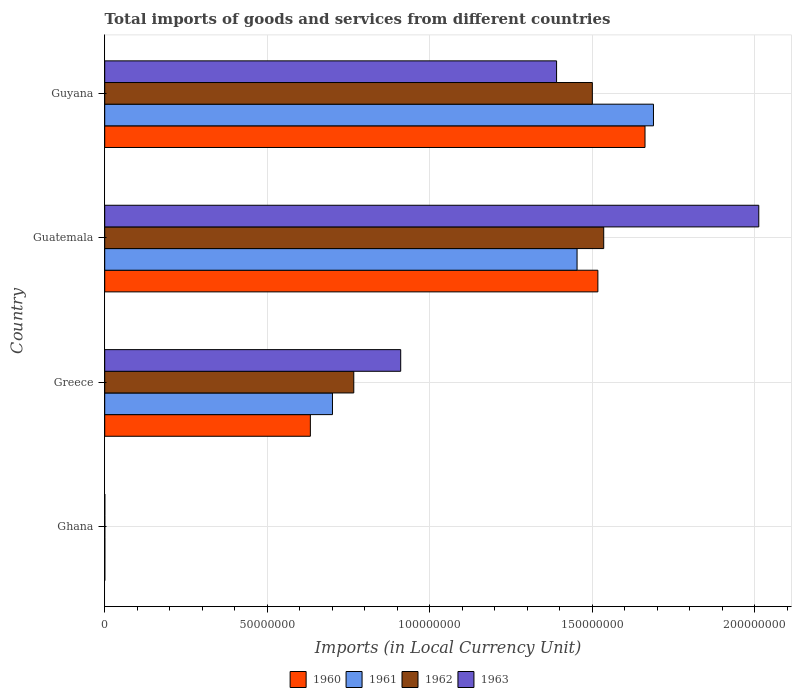How many bars are there on the 2nd tick from the bottom?
Keep it short and to the point. 4. What is the Amount of goods and services imports in 1960 in Guatemala?
Your response must be concise. 1.52e+08. Across all countries, what is the maximum Amount of goods and services imports in 1961?
Your answer should be very brief. 1.69e+08. Across all countries, what is the minimum Amount of goods and services imports in 1963?
Provide a succinct answer. 3.02e+04. In which country was the Amount of goods and services imports in 1963 maximum?
Make the answer very short. Guatemala. What is the total Amount of goods and services imports in 1962 in the graph?
Provide a short and direct response. 3.80e+08. What is the difference between the Amount of goods and services imports in 1963 in Ghana and that in Greece?
Make the answer very short. -9.10e+07. What is the difference between the Amount of goods and services imports in 1963 in Guyana and the Amount of goods and services imports in 1960 in Greece?
Give a very brief answer. 7.57e+07. What is the average Amount of goods and services imports in 1962 per country?
Give a very brief answer. 9.50e+07. What is the difference between the Amount of goods and services imports in 1963 and Amount of goods and services imports in 1960 in Guatemala?
Make the answer very short. 4.95e+07. In how many countries, is the Amount of goods and services imports in 1960 greater than 200000000 LCU?
Keep it short and to the point. 0. What is the ratio of the Amount of goods and services imports in 1961 in Greece to that in Guyana?
Your answer should be compact. 0.42. Is the Amount of goods and services imports in 1961 in Guatemala less than that in Guyana?
Ensure brevity in your answer.  Yes. Is the difference between the Amount of goods and services imports in 1963 in Guatemala and Guyana greater than the difference between the Amount of goods and services imports in 1960 in Guatemala and Guyana?
Your answer should be very brief. Yes. What is the difference between the highest and the second highest Amount of goods and services imports in 1960?
Ensure brevity in your answer.  1.45e+07. What is the difference between the highest and the lowest Amount of goods and services imports in 1960?
Offer a terse response. 1.66e+08. Is the sum of the Amount of goods and services imports in 1960 in Greece and Guatemala greater than the maximum Amount of goods and services imports in 1961 across all countries?
Offer a very short reply. Yes. What does the 1st bar from the top in Ghana represents?
Your answer should be compact. 1963. What does the 4th bar from the bottom in Ghana represents?
Offer a very short reply. 1963. How many countries are there in the graph?
Keep it short and to the point. 4. What is the difference between two consecutive major ticks on the X-axis?
Provide a succinct answer. 5.00e+07. Does the graph contain any zero values?
Provide a succinct answer. No. Does the graph contain grids?
Offer a very short reply. Yes. How many legend labels are there?
Provide a short and direct response. 4. What is the title of the graph?
Make the answer very short. Total imports of goods and services from different countries. What is the label or title of the X-axis?
Your response must be concise. Imports (in Local Currency Unit). What is the label or title of the Y-axis?
Give a very brief answer. Country. What is the Imports (in Local Currency Unit) in 1960 in Ghana?
Your answer should be very brief. 3.08e+04. What is the Imports (in Local Currency Unit) in 1961 in Ghana?
Offer a terse response. 3.39e+04. What is the Imports (in Local Currency Unit) in 1962 in Ghana?
Ensure brevity in your answer.  2.81e+04. What is the Imports (in Local Currency Unit) of 1963 in Ghana?
Offer a very short reply. 3.02e+04. What is the Imports (in Local Currency Unit) of 1960 in Greece?
Ensure brevity in your answer.  6.33e+07. What is the Imports (in Local Currency Unit) of 1961 in Greece?
Make the answer very short. 7.01e+07. What is the Imports (in Local Currency Unit) in 1962 in Greece?
Offer a very short reply. 7.66e+07. What is the Imports (in Local Currency Unit) in 1963 in Greece?
Your response must be concise. 9.10e+07. What is the Imports (in Local Currency Unit) of 1960 in Guatemala?
Ensure brevity in your answer.  1.52e+08. What is the Imports (in Local Currency Unit) in 1961 in Guatemala?
Offer a terse response. 1.45e+08. What is the Imports (in Local Currency Unit) of 1962 in Guatemala?
Provide a succinct answer. 1.54e+08. What is the Imports (in Local Currency Unit) in 1963 in Guatemala?
Your answer should be compact. 2.01e+08. What is the Imports (in Local Currency Unit) of 1960 in Guyana?
Make the answer very short. 1.66e+08. What is the Imports (in Local Currency Unit) of 1961 in Guyana?
Offer a very short reply. 1.69e+08. What is the Imports (in Local Currency Unit) of 1962 in Guyana?
Provide a short and direct response. 1.50e+08. What is the Imports (in Local Currency Unit) in 1963 in Guyana?
Your response must be concise. 1.39e+08. Across all countries, what is the maximum Imports (in Local Currency Unit) in 1960?
Keep it short and to the point. 1.66e+08. Across all countries, what is the maximum Imports (in Local Currency Unit) of 1961?
Your response must be concise. 1.69e+08. Across all countries, what is the maximum Imports (in Local Currency Unit) of 1962?
Keep it short and to the point. 1.54e+08. Across all countries, what is the maximum Imports (in Local Currency Unit) of 1963?
Offer a very short reply. 2.01e+08. Across all countries, what is the minimum Imports (in Local Currency Unit) of 1960?
Your answer should be very brief. 3.08e+04. Across all countries, what is the minimum Imports (in Local Currency Unit) in 1961?
Provide a short and direct response. 3.39e+04. Across all countries, what is the minimum Imports (in Local Currency Unit) in 1962?
Offer a terse response. 2.81e+04. Across all countries, what is the minimum Imports (in Local Currency Unit) of 1963?
Make the answer very short. 3.02e+04. What is the total Imports (in Local Currency Unit) of 1960 in the graph?
Provide a succinct answer. 3.81e+08. What is the total Imports (in Local Currency Unit) of 1961 in the graph?
Provide a short and direct response. 3.84e+08. What is the total Imports (in Local Currency Unit) of 1962 in the graph?
Give a very brief answer. 3.80e+08. What is the total Imports (in Local Currency Unit) of 1963 in the graph?
Make the answer very short. 4.31e+08. What is the difference between the Imports (in Local Currency Unit) of 1960 in Ghana and that in Greece?
Provide a short and direct response. -6.32e+07. What is the difference between the Imports (in Local Currency Unit) of 1961 in Ghana and that in Greece?
Ensure brevity in your answer.  -7.00e+07. What is the difference between the Imports (in Local Currency Unit) of 1962 in Ghana and that in Greece?
Ensure brevity in your answer.  -7.66e+07. What is the difference between the Imports (in Local Currency Unit) in 1963 in Ghana and that in Greece?
Your answer should be compact. -9.10e+07. What is the difference between the Imports (in Local Currency Unit) in 1960 in Ghana and that in Guatemala?
Keep it short and to the point. -1.52e+08. What is the difference between the Imports (in Local Currency Unit) of 1961 in Ghana and that in Guatemala?
Provide a succinct answer. -1.45e+08. What is the difference between the Imports (in Local Currency Unit) of 1962 in Ghana and that in Guatemala?
Provide a succinct answer. -1.53e+08. What is the difference between the Imports (in Local Currency Unit) of 1963 in Ghana and that in Guatemala?
Ensure brevity in your answer.  -2.01e+08. What is the difference between the Imports (in Local Currency Unit) in 1960 in Ghana and that in Guyana?
Provide a succinct answer. -1.66e+08. What is the difference between the Imports (in Local Currency Unit) in 1961 in Ghana and that in Guyana?
Keep it short and to the point. -1.69e+08. What is the difference between the Imports (in Local Currency Unit) of 1962 in Ghana and that in Guyana?
Your answer should be compact. -1.50e+08. What is the difference between the Imports (in Local Currency Unit) in 1963 in Ghana and that in Guyana?
Make the answer very short. -1.39e+08. What is the difference between the Imports (in Local Currency Unit) of 1960 in Greece and that in Guatemala?
Make the answer very short. -8.84e+07. What is the difference between the Imports (in Local Currency Unit) of 1961 in Greece and that in Guatemala?
Provide a succinct answer. -7.52e+07. What is the difference between the Imports (in Local Currency Unit) of 1962 in Greece and that in Guatemala?
Keep it short and to the point. -7.69e+07. What is the difference between the Imports (in Local Currency Unit) in 1963 in Greece and that in Guatemala?
Provide a short and direct response. -1.10e+08. What is the difference between the Imports (in Local Currency Unit) in 1960 in Greece and that in Guyana?
Your answer should be compact. -1.03e+08. What is the difference between the Imports (in Local Currency Unit) of 1961 in Greece and that in Guyana?
Your answer should be compact. -9.87e+07. What is the difference between the Imports (in Local Currency Unit) of 1962 in Greece and that in Guyana?
Your answer should be very brief. -7.34e+07. What is the difference between the Imports (in Local Currency Unit) in 1963 in Greece and that in Guyana?
Your response must be concise. -4.80e+07. What is the difference between the Imports (in Local Currency Unit) of 1960 in Guatemala and that in Guyana?
Give a very brief answer. -1.45e+07. What is the difference between the Imports (in Local Currency Unit) in 1961 in Guatemala and that in Guyana?
Provide a succinct answer. -2.35e+07. What is the difference between the Imports (in Local Currency Unit) of 1962 in Guatemala and that in Guyana?
Your response must be concise. 3.50e+06. What is the difference between the Imports (in Local Currency Unit) in 1963 in Guatemala and that in Guyana?
Make the answer very short. 6.22e+07. What is the difference between the Imports (in Local Currency Unit) of 1960 in Ghana and the Imports (in Local Currency Unit) of 1961 in Greece?
Your answer should be very brief. -7.00e+07. What is the difference between the Imports (in Local Currency Unit) of 1960 in Ghana and the Imports (in Local Currency Unit) of 1962 in Greece?
Ensure brevity in your answer.  -7.66e+07. What is the difference between the Imports (in Local Currency Unit) of 1960 in Ghana and the Imports (in Local Currency Unit) of 1963 in Greece?
Your answer should be very brief. -9.10e+07. What is the difference between the Imports (in Local Currency Unit) of 1961 in Ghana and the Imports (in Local Currency Unit) of 1962 in Greece?
Provide a succinct answer. -7.66e+07. What is the difference between the Imports (in Local Currency Unit) in 1961 in Ghana and the Imports (in Local Currency Unit) in 1963 in Greece?
Your response must be concise. -9.10e+07. What is the difference between the Imports (in Local Currency Unit) of 1962 in Ghana and the Imports (in Local Currency Unit) of 1963 in Greece?
Keep it short and to the point. -9.10e+07. What is the difference between the Imports (in Local Currency Unit) in 1960 in Ghana and the Imports (in Local Currency Unit) in 1961 in Guatemala?
Ensure brevity in your answer.  -1.45e+08. What is the difference between the Imports (in Local Currency Unit) in 1960 in Ghana and the Imports (in Local Currency Unit) in 1962 in Guatemala?
Your response must be concise. -1.53e+08. What is the difference between the Imports (in Local Currency Unit) in 1960 in Ghana and the Imports (in Local Currency Unit) in 1963 in Guatemala?
Your answer should be very brief. -2.01e+08. What is the difference between the Imports (in Local Currency Unit) in 1961 in Ghana and the Imports (in Local Currency Unit) in 1962 in Guatemala?
Your answer should be very brief. -1.53e+08. What is the difference between the Imports (in Local Currency Unit) in 1961 in Ghana and the Imports (in Local Currency Unit) in 1963 in Guatemala?
Ensure brevity in your answer.  -2.01e+08. What is the difference between the Imports (in Local Currency Unit) in 1962 in Ghana and the Imports (in Local Currency Unit) in 1963 in Guatemala?
Give a very brief answer. -2.01e+08. What is the difference between the Imports (in Local Currency Unit) in 1960 in Ghana and the Imports (in Local Currency Unit) in 1961 in Guyana?
Provide a short and direct response. -1.69e+08. What is the difference between the Imports (in Local Currency Unit) in 1960 in Ghana and the Imports (in Local Currency Unit) in 1962 in Guyana?
Offer a very short reply. -1.50e+08. What is the difference between the Imports (in Local Currency Unit) of 1960 in Ghana and the Imports (in Local Currency Unit) of 1963 in Guyana?
Give a very brief answer. -1.39e+08. What is the difference between the Imports (in Local Currency Unit) of 1961 in Ghana and the Imports (in Local Currency Unit) of 1962 in Guyana?
Your answer should be compact. -1.50e+08. What is the difference between the Imports (in Local Currency Unit) in 1961 in Ghana and the Imports (in Local Currency Unit) in 1963 in Guyana?
Make the answer very short. -1.39e+08. What is the difference between the Imports (in Local Currency Unit) in 1962 in Ghana and the Imports (in Local Currency Unit) in 1963 in Guyana?
Give a very brief answer. -1.39e+08. What is the difference between the Imports (in Local Currency Unit) in 1960 in Greece and the Imports (in Local Currency Unit) in 1961 in Guatemala?
Provide a short and direct response. -8.20e+07. What is the difference between the Imports (in Local Currency Unit) of 1960 in Greece and the Imports (in Local Currency Unit) of 1962 in Guatemala?
Your response must be concise. -9.02e+07. What is the difference between the Imports (in Local Currency Unit) of 1960 in Greece and the Imports (in Local Currency Unit) of 1963 in Guatemala?
Provide a succinct answer. -1.38e+08. What is the difference between the Imports (in Local Currency Unit) in 1961 in Greece and the Imports (in Local Currency Unit) in 1962 in Guatemala?
Ensure brevity in your answer.  -8.34e+07. What is the difference between the Imports (in Local Currency Unit) of 1961 in Greece and the Imports (in Local Currency Unit) of 1963 in Guatemala?
Provide a succinct answer. -1.31e+08. What is the difference between the Imports (in Local Currency Unit) in 1962 in Greece and the Imports (in Local Currency Unit) in 1963 in Guatemala?
Provide a short and direct response. -1.25e+08. What is the difference between the Imports (in Local Currency Unit) in 1960 in Greece and the Imports (in Local Currency Unit) in 1961 in Guyana?
Keep it short and to the point. -1.06e+08. What is the difference between the Imports (in Local Currency Unit) of 1960 in Greece and the Imports (in Local Currency Unit) of 1962 in Guyana?
Your answer should be compact. -8.67e+07. What is the difference between the Imports (in Local Currency Unit) of 1960 in Greece and the Imports (in Local Currency Unit) of 1963 in Guyana?
Offer a very short reply. -7.57e+07. What is the difference between the Imports (in Local Currency Unit) in 1961 in Greece and the Imports (in Local Currency Unit) in 1962 in Guyana?
Make the answer very short. -7.99e+07. What is the difference between the Imports (in Local Currency Unit) in 1961 in Greece and the Imports (in Local Currency Unit) in 1963 in Guyana?
Your response must be concise. -6.89e+07. What is the difference between the Imports (in Local Currency Unit) of 1962 in Greece and the Imports (in Local Currency Unit) of 1963 in Guyana?
Offer a very short reply. -6.24e+07. What is the difference between the Imports (in Local Currency Unit) of 1960 in Guatemala and the Imports (in Local Currency Unit) of 1961 in Guyana?
Provide a short and direct response. -1.71e+07. What is the difference between the Imports (in Local Currency Unit) of 1960 in Guatemala and the Imports (in Local Currency Unit) of 1962 in Guyana?
Offer a very short reply. 1.70e+06. What is the difference between the Imports (in Local Currency Unit) of 1960 in Guatemala and the Imports (in Local Currency Unit) of 1963 in Guyana?
Your response must be concise. 1.27e+07. What is the difference between the Imports (in Local Currency Unit) in 1961 in Guatemala and the Imports (in Local Currency Unit) in 1962 in Guyana?
Your answer should be very brief. -4.70e+06. What is the difference between the Imports (in Local Currency Unit) in 1961 in Guatemala and the Imports (in Local Currency Unit) in 1963 in Guyana?
Your answer should be compact. 6.30e+06. What is the difference between the Imports (in Local Currency Unit) in 1962 in Guatemala and the Imports (in Local Currency Unit) in 1963 in Guyana?
Your answer should be very brief. 1.45e+07. What is the average Imports (in Local Currency Unit) in 1960 per country?
Your response must be concise. 9.53e+07. What is the average Imports (in Local Currency Unit) in 1961 per country?
Your answer should be very brief. 9.60e+07. What is the average Imports (in Local Currency Unit) of 1962 per country?
Ensure brevity in your answer.  9.50e+07. What is the average Imports (in Local Currency Unit) in 1963 per country?
Provide a succinct answer. 1.08e+08. What is the difference between the Imports (in Local Currency Unit) in 1960 and Imports (in Local Currency Unit) in 1961 in Ghana?
Make the answer very short. -3100. What is the difference between the Imports (in Local Currency Unit) of 1960 and Imports (in Local Currency Unit) of 1962 in Ghana?
Your answer should be very brief. 2700. What is the difference between the Imports (in Local Currency Unit) in 1960 and Imports (in Local Currency Unit) in 1963 in Ghana?
Provide a succinct answer. 600. What is the difference between the Imports (in Local Currency Unit) of 1961 and Imports (in Local Currency Unit) of 1962 in Ghana?
Your response must be concise. 5800. What is the difference between the Imports (in Local Currency Unit) in 1961 and Imports (in Local Currency Unit) in 1963 in Ghana?
Offer a very short reply. 3700. What is the difference between the Imports (in Local Currency Unit) in 1962 and Imports (in Local Currency Unit) in 1963 in Ghana?
Your response must be concise. -2100. What is the difference between the Imports (in Local Currency Unit) in 1960 and Imports (in Local Currency Unit) in 1961 in Greece?
Your response must be concise. -6.80e+06. What is the difference between the Imports (in Local Currency Unit) in 1960 and Imports (in Local Currency Unit) in 1962 in Greece?
Give a very brief answer. -1.34e+07. What is the difference between the Imports (in Local Currency Unit) of 1960 and Imports (in Local Currency Unit) of 1963 in Greece?
Provide a short and direct response. -2.78e+07. What is the difference between the Imports (in Local Currency Unit) in 1961 and Imports (in Local Currency Unit) in 1962 in Greece?
Offer a terse response. -6.56e+06. What is the difference between the Imports (in Local Currency Unit) in 1961 and Imports (in Local Currency Unit) in 1963 in Greece?
Your answer should be very brief. -2.10e+07. What is the difference between the Imports (in Local Currency Unit) of 1962 and Imports (in Local Currency Unit) of 1963 in Greece?
Provide a short and direct response. -1.44e+07. What is the difference between the Imports (in Local Currency Unit) of 1960 and Imports (in Local Currency Unit) of 1961 in Guatemala?
Give a very brief answer. 6.40e+06. What is the difference between the Imports (in Local Currency Unit) in 1960 and Imports (in Local Currency Unit) in 1962 in Guatemala?
Your response must be concise. -1.80e+06. What is the difference between the Imports (in Local Currency Unit) in 1960 and Imports (in Local Currency Unit) in 1963 in Guatemala?
Give a very brief answer. -4.95e+07. What is the difference between the Imports (in Local Currency Unit) of 1961 and Imports (in Local Currency Unit) of 1962 in Guatemala?
Make the answer very short. -8.20e+06. What is the difference between the Imports (in Local Currency Unit) in 1961 and Imports (in Local Currency Unit) in 1963 in Guatemala?
Make the answer very short. -5.59e+07. What is the difference between the Imports (in Local Currency Unit) in 1962 and Imports (in Local Currency Unit) in 1963 in Guatemala?
Offer a terse response. -4.77e+07. What is the difference between the Imports (in Local Currency Unit) in 1960 and Imports (in Local Currency Unit) in 1961 in Guyana?
Provide a succinct answer. -2.60e+06. What is the difference between the Imports (in Local Currency Unit) in 1960 and Imports (in Local Currency Unit) in 1962 in Guyana?
Keep it short and to the point. 1.62e+07. What is the difference between the Imports (in Local Currency Unit) of 1960 and Imports (in Local Currency Unit) of 1963 in Guyana?
Give a very brief answer. 2.72e+07. What is the difference between the Imports (in Local Currency Unit) in 1961 and Imports (in Local Currency Unit) in 1962 in Guyana?
Your answer should be very brief. 1.88e+07. What is the difference between the Imports (in Local Currency Unit) in 1961 and Imports (in Local Currency Unit) in 1963 in Guyana?
Provide a succinct answer. 2.98e+07. What is the difference between the Imports (in Local Currency Unit) of 1962 and Imports (in Local Currency Unit) of 1963 in Guyana?
Give a very brief answer. 1.10e+07. What is the ratio of the Imports (in Local Currency Unit) of 1960 in Ghana to that in Greece?
Ensure brevity in your answer.  0. What is the ratio of the Imports (in Local Currency Unit) in 1961 in Ghana to that in Greece?
Your answer should be very brief. 0. What is the ratio of the Imports (in Local Currency Unit) in 1963 in Ghana to that in Greece?
Your answer should be compact. 0. What is the ratio of the Imports (in Local Currency Unit) of 1960 in Ghana to that in Guatemala?
Make the answer very short. 0. What is the ratio of the Imports (in Local Currency Unit) in 1962 in Ghana to that in Guatemala?
Offer a terse response. 0. What is the ratio of the Imports (in Local Currency Unit) of 1961 in Ghana to that in Guyana?
Provide a short and direct response. 0. What is the ratio of the Imports (in Local Currency Unit) of 1962 in Ghana to that in Guyana?
Ensure brevity in your answer.  0. What is the ratio of the Imports (in Local Currency Unit) in 1963 in Ghana to that in Guyana?
Provide a succinct answer. 0. What is the ratio of the Imports (in Local Currency Unit) in 1960 in Greece to that in Guatemala?
Offer a very short reply. 0.42. What is the ratio of the Imports (in Local Currency Unit) of 1961 in Greece to that in Guatemala?
Offer a terse response. 0.48. What is the ratio of the Imports (in Local Currency Unit) in 1962 in Greece to that in Guatemala?
Your response must be concise. 0.5. What is the ratio of the Imports (in Local Currency Unit) in 1963 in Greece to that in Guatemala?
Ensure brevity in your answer.  0.45. What is the ratio of the Imports (in Local Currency Unit) in 1960 in Greece to that in Guyana?
Make the answer very short. 0.38. What is the ratio of the Imports (in Local Currency Unit) in 1961 in Greece to that in Guyana?
Ensure brevity in your answer.  0.41. What is the ratio of the Imports (in Local Currency Unit) of 1962 in Greece to that in Guyana?
Keep it short and to the point. 0.51. What is the ratio of the Imports (in Local Currency Unit) of 1963 in Greece to that in Guyana?
Provide a succinct answer. 0.66. What is the ratio of the Imports (in Local Currency Unit) of 1960 in Guatemala to that in Guyana?
Keep it short and to the point. 0.91. What is the ratio of the Imports (in Local Currency Unit) in 1961 in Guatemala to that in Guyana?
Offer a very short reply. 0.86. What is the ratio of the Imports (in Local Currency Unit) of 1962 in Guatemala to that in Guyana?
Provide a short and direct response. 1.02. What is the ratio of the Imports (in Local Currency Unit) in 1963 in Guatemala to that in Guyana?
Ensure brevity in your answer.  1.45. What is the difference between the highest and the second highest Imports (in Local Currency Unit) in 1960?
Keep it short and to the point. 1.45e+07. What is the difference between the highest and the second highest Imports (in Local Currency Unit) in 1961?
Your answer should be very brief. 2.35e+07. What is the difference between the highest and the second highest Imports (in Local Currency Unit) in 1962?
Your answer should be very brief. 3.50e+06. What is the difference between the highest and the second highest Imports (in Local Currency Unit) of 1963?
Keep it short and to the point. 6.22e+07. What is the difference between the highest and the lowest Imports (in Local Currency Unit) of 1960?
Your answer should be very brief. 1.66e+08. What is the difference between the highest and the lowest Imports (in Local Currency Unit) of 1961?
Your answer should be compact. 1.69e+08. What is the difference between the highest and the lowest Imports (in Local Currency Unit) in 1962?
Offer a terse response. 1.53e+08. What is the difference between the highest and the lowest Imports (in Local Currency Unit) in 1963?
Offer a very short reply. 2.01e+08. 